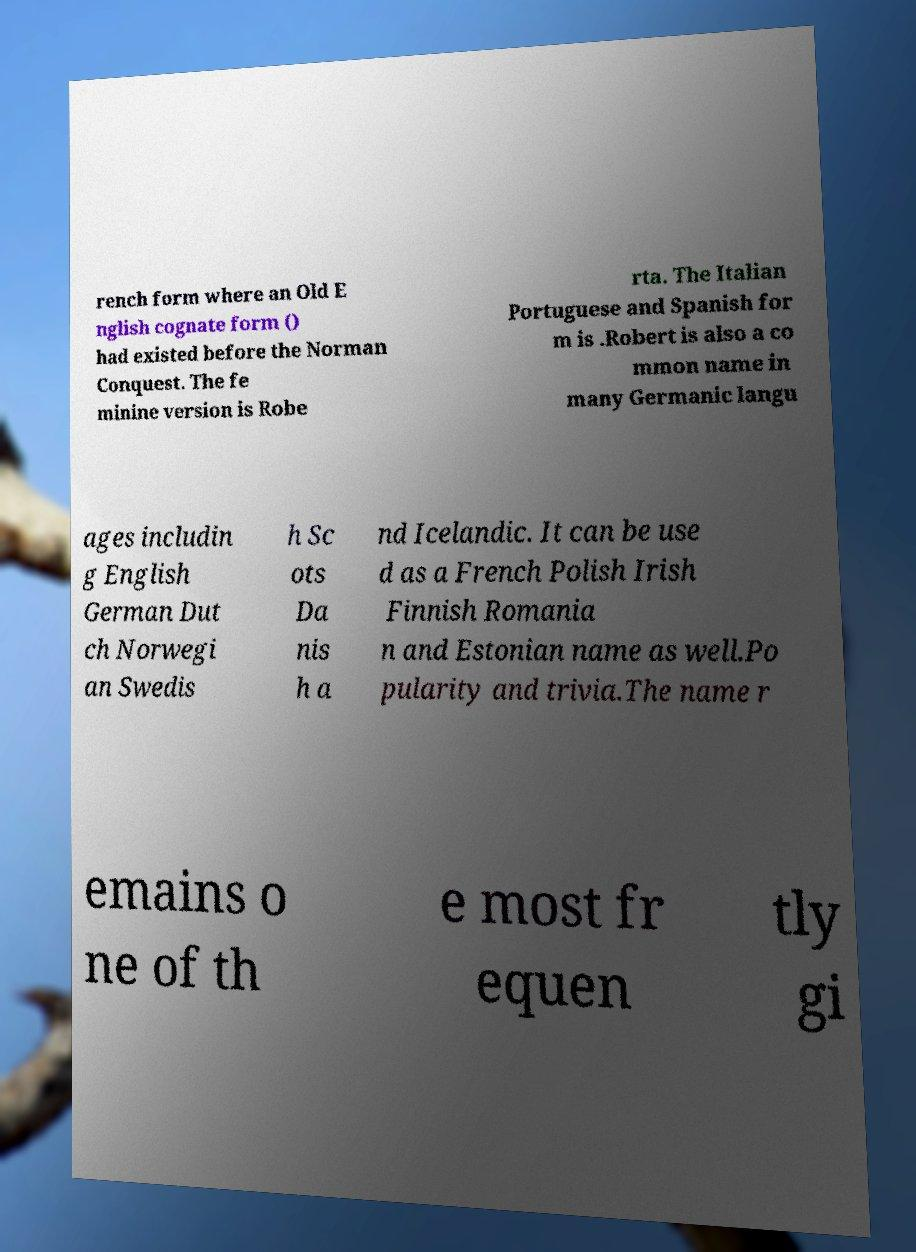Please read and relay the text visible in this image. What does it say? rench form where an Old E nglish cognate form () had existed before the Norman Conquest. The fe minine version is Robe rta. The Italian Portuguese and Spanish for m is .Robert is also a co mmon name in many Germanic langu ages includin g English German Dut ch Norwegi an Swedis h Sc ots Da nis h a nd Icelandic. It can be use d as a French Polish Irish Finnish Romania n and Estonian name as well.Po pularity and trivia.The name r emains o ne of th e most fr equen tly gi 